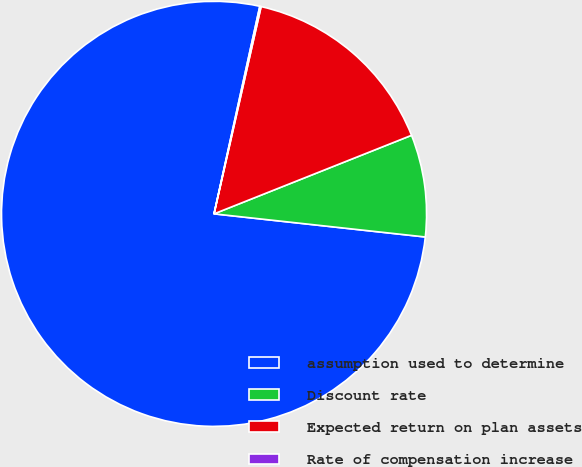Convert chart. <chart><loc_0><loc_0><loc_500><loc_500><pie_chart><fcel>assumption used to determine<fcel>Discount rate<fcel>Expected return on plan assets<fcel>Rate of compensation increase<nl><fcel>76.71%<fcel>7.76%<fcel>15.42%<fcel>0.1%<nl></chart> 